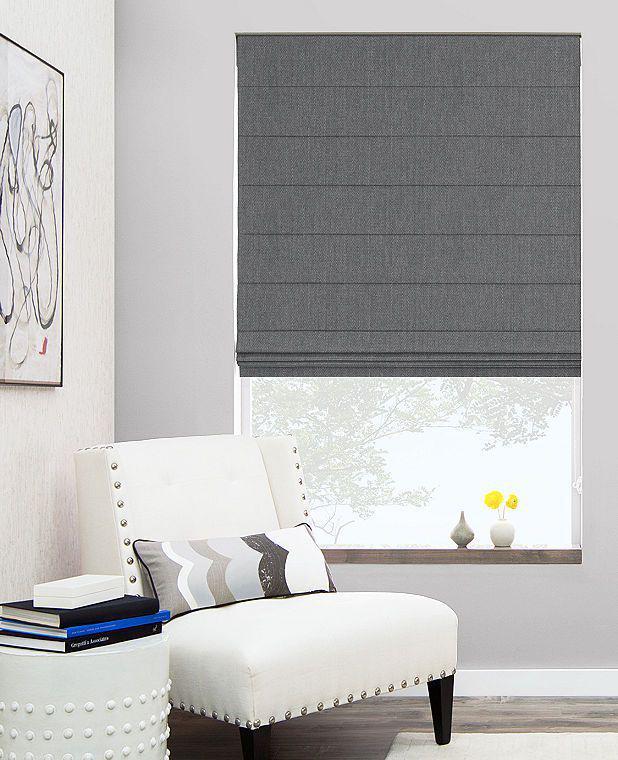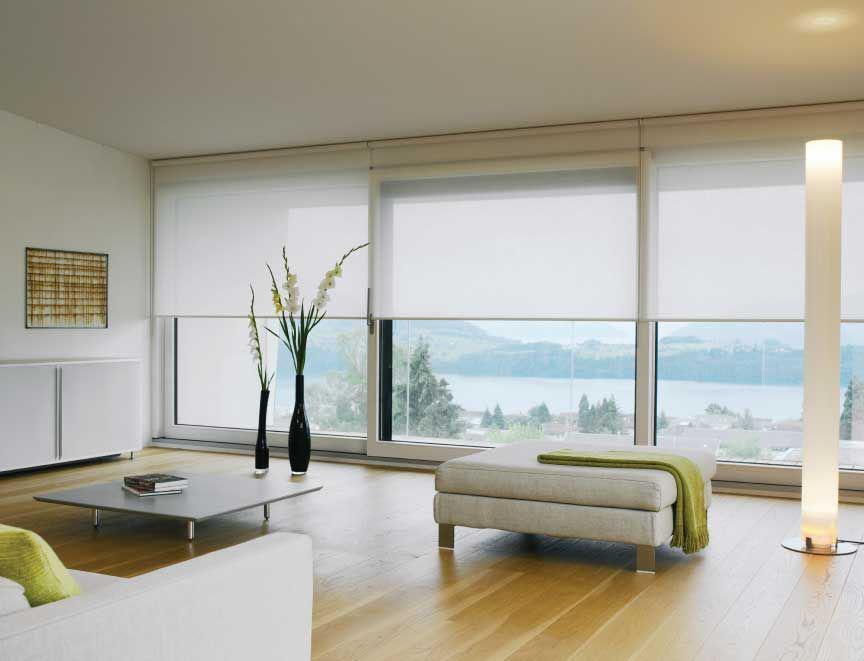The first image is the image on the left, the second image is the image on the right. For the images shown, is this caption "In the image to the left, you can see the lamp." true? Answer yes or no. No. The first image is the image on the left, the second image is the image on the right. Evaluate the accuracy of this statement regarding the images: "There are three window shades in one image, and four window shades in the other image.". Is it true? Answer yes or no. No. 